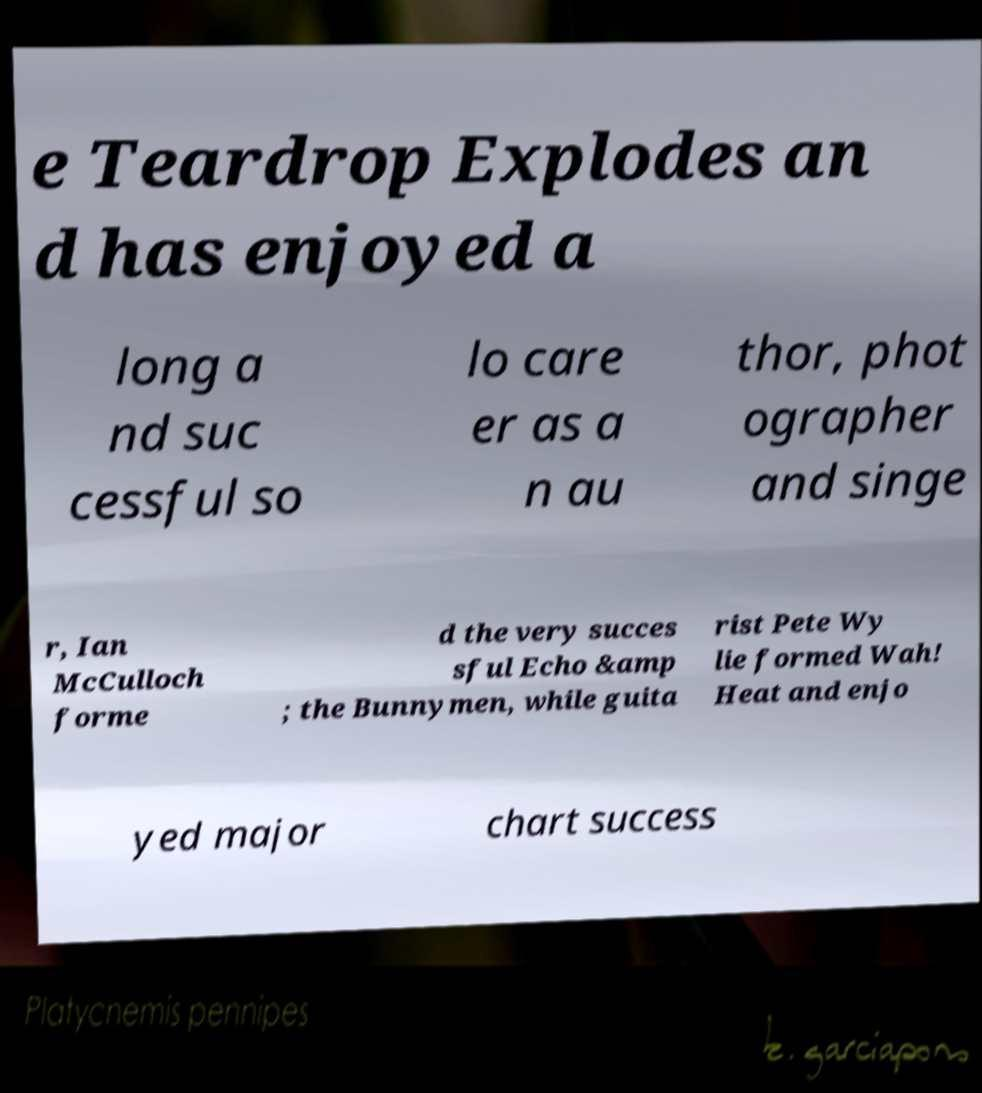Could you extract and type out the text from this image? e Teardrop Explodes an d has enjoyed a long a nd suc cessful so lo care er as a n au thor, phot ographer and singe r, Ian McCulloch forme d the very succes sful Echo &amp ; the Bunnymen, while guita rist Pete Wy lie formed Wah! Heat and enjo yed major chart success 